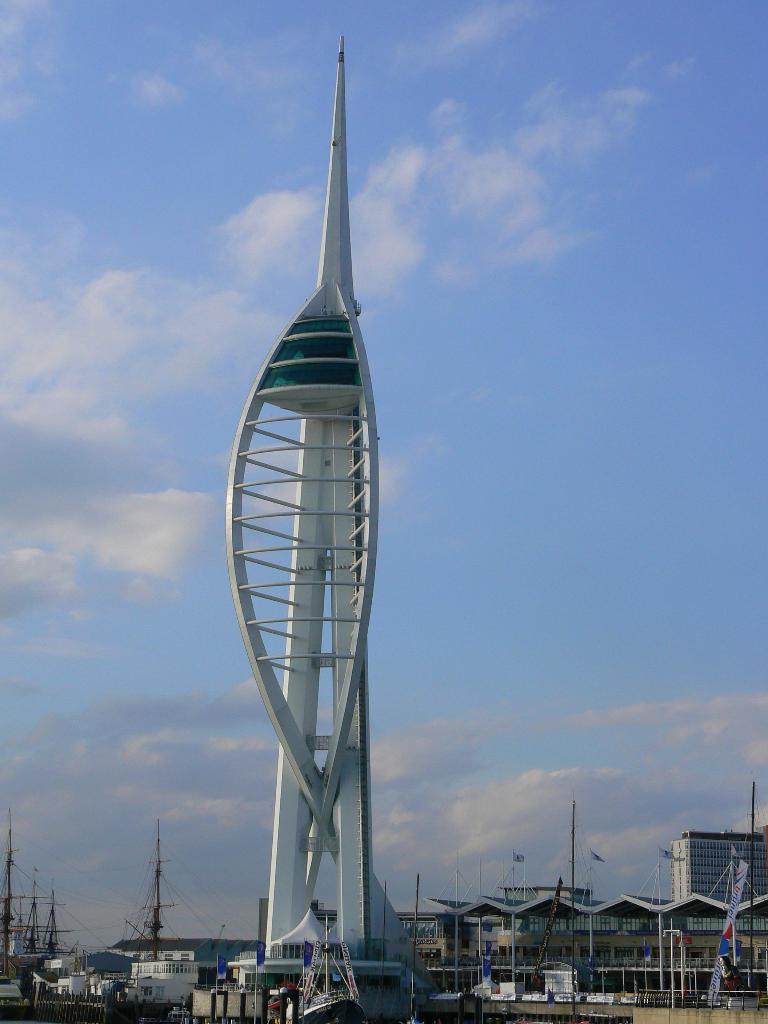What is the main structure in the image? There is a tower in the image. What other objects can be seen in the image? There are poles, buildings, and banners in the image. What is visible in the background of the image? The sky is visible in the background of the image. What can be observed in the sky? Clouds are present in the sky. What type of plastic material is used to make the sofa in the image? There is no sofa present in the image; it features a tower, poles, buildings, banners, and a sky with clouds. 